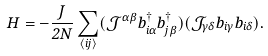Convert formula to latex. <formula><loc_0><loc_0><loc_500><loc_500>H = - \frac { J } { 2 N } \sum _ { \langle i j \rangle } ( { \mathcal { J } } ^ { \alpha \beta } b ^ { \dagger } _ { i \alpha } b ^ { \dagger } _ { j \beta } ) ( { \mathcal { J } } _ { \gamma \delta } b _ { i \gamma } b _ { i \delta } ) .</formula> 